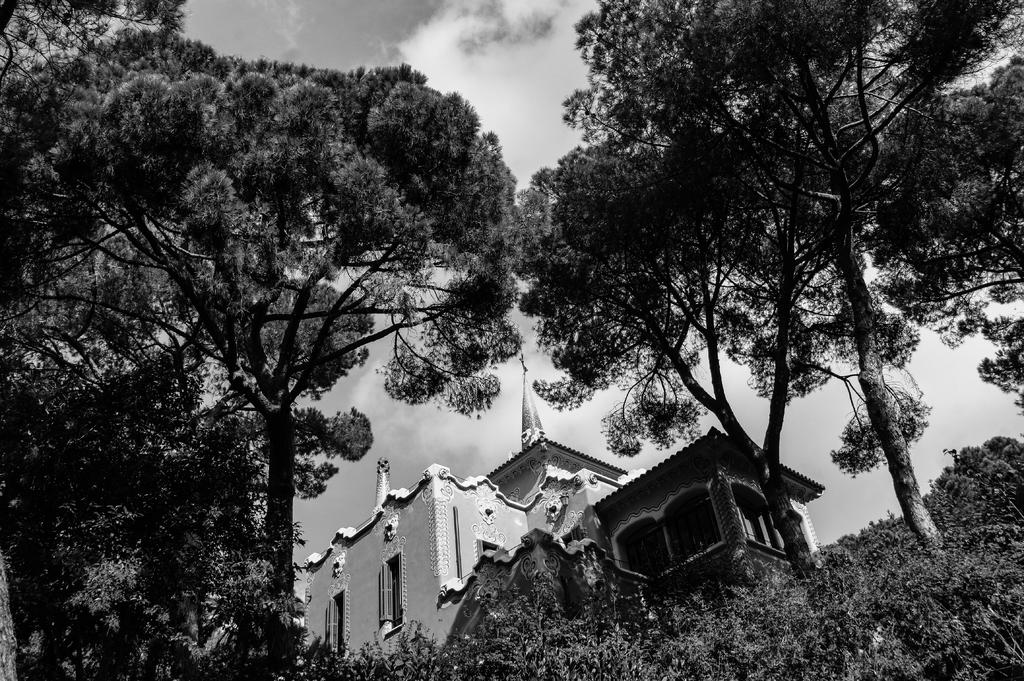What is the color scheme of the image? The image is black and white. What type of structure can be seen in the image? There is a building in the image. What other elements are present in the image besides the building? There are trees in the image. What can be seen in the background of the image? The sky is visible in the background of the image. How many knots are tied on the tree in the image? There are no knots present in the image, as it is a black and white image featuring a building, trees, and the sky. Can you describe the group of people gathered around the building in the image? There are no people present in the image; it only features a building, trees, and the sky. 